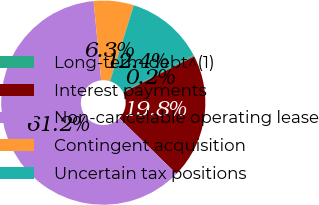Convert chart. <chart><loc_0><loc_0><loc_500><loc_500><pie_chart><fcel>Long-term debt^(1)<fcel>Interest payments<fcel>Non-cancelable operating lease<fcel>Contingent acquisition<fcel>Uncertain tax positions<nl><fcel>0.24%<fcel>19.77%<fcel>61.21%<fcel>6.34%<fcel>12.44%<nl></chart> 